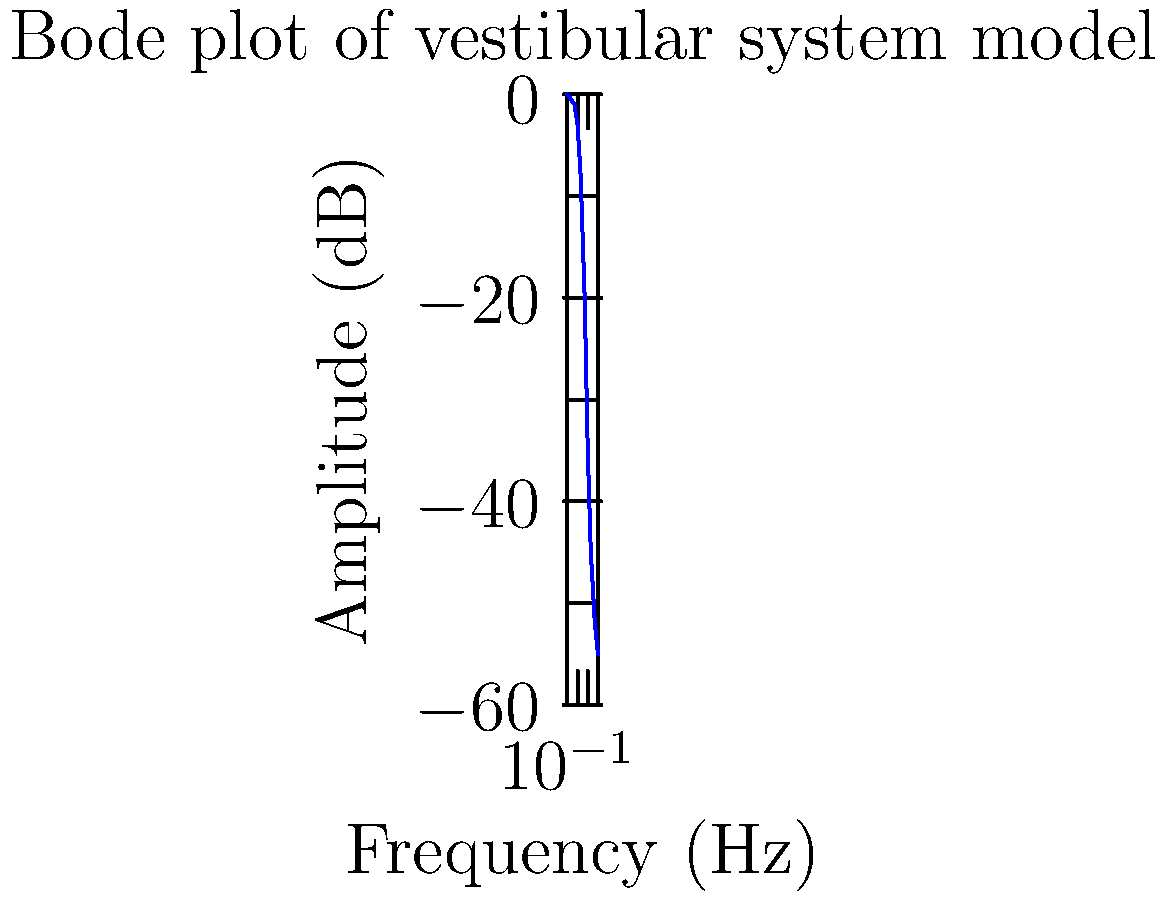Based on the Bode plot of a mechanical model representing the vestibular system, at approximately what frequency does the amplitude response begin to significantly decrease (roll-off)? To determine the frequency at which the amplitude response begins to significantly decrease (roll-off), we need to analyze the Bode plot:

1. Observe the overall trend of the plot from left to right.
2. Look for a point where the curve starts to consistently decrease with a steeper slope.
3. This point is typically around -3 dB to -6 dB, known as the cutoff frequency or corner frequency.

Analyzing the plot:
1. The amplitude remains relatively constant from 0.1 Hz to about 1 Hz.
2. Between 1 Hz and 2 Hz, we see the beginning of a consistent downward trend.
3. At 2 Hz, the amplitude is approximately -8 dB, which is past the typical -3 dB to -6 dB range for the cutoff frequency.

Therefore, the roll-off begins slightly before 2 Hz, approximately around 1 Hz to 1.5 Hz.

This frequency is significant in vestibular system modeling as it represents the point where the system's ability to respond to input stimuli begins to diminish, which is crucial for understanding the limitations of vestibular function in different frequency ranges of head movement.
Answer: Approximately 1 Hz 